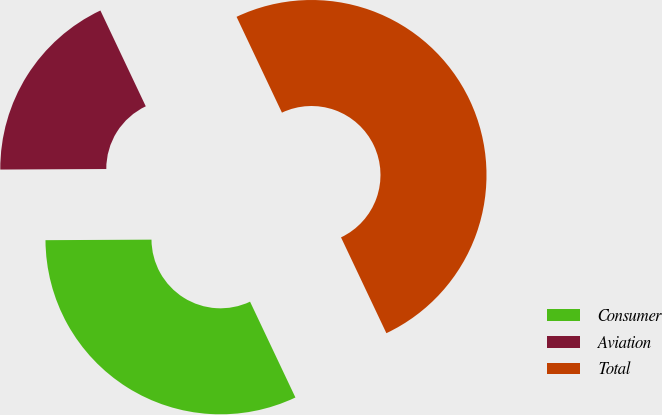Convert chart. <chart><loc_0><loc_0><loc_500><loc_500><pie_chart><fcel>Consumer<fcel>Aviation<fcel>Total<nl><fcel>31.96%<fcel>18.04%<fcel>50.0%<nl></chart> 